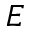<formula> <loc_0><loc_0><loc_500><loc_500>E</formula> 